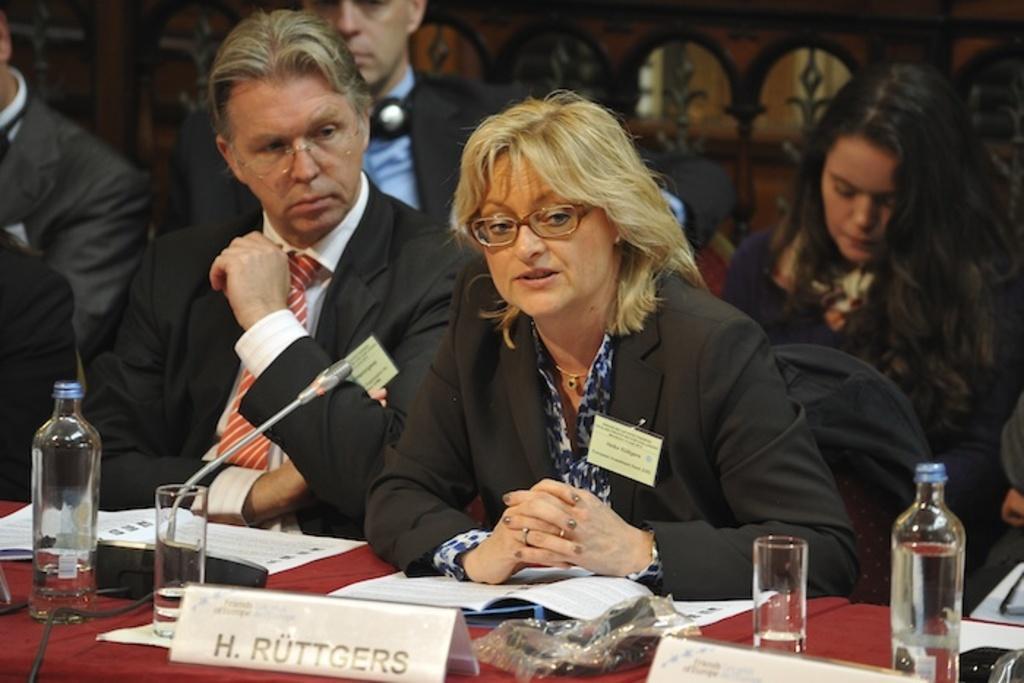Describe this image in one or two sentences. In this image we can see group of persons and behind the persons we can see few chairs and a group of objects. In front of the persons we can see group of objects on a surface. 